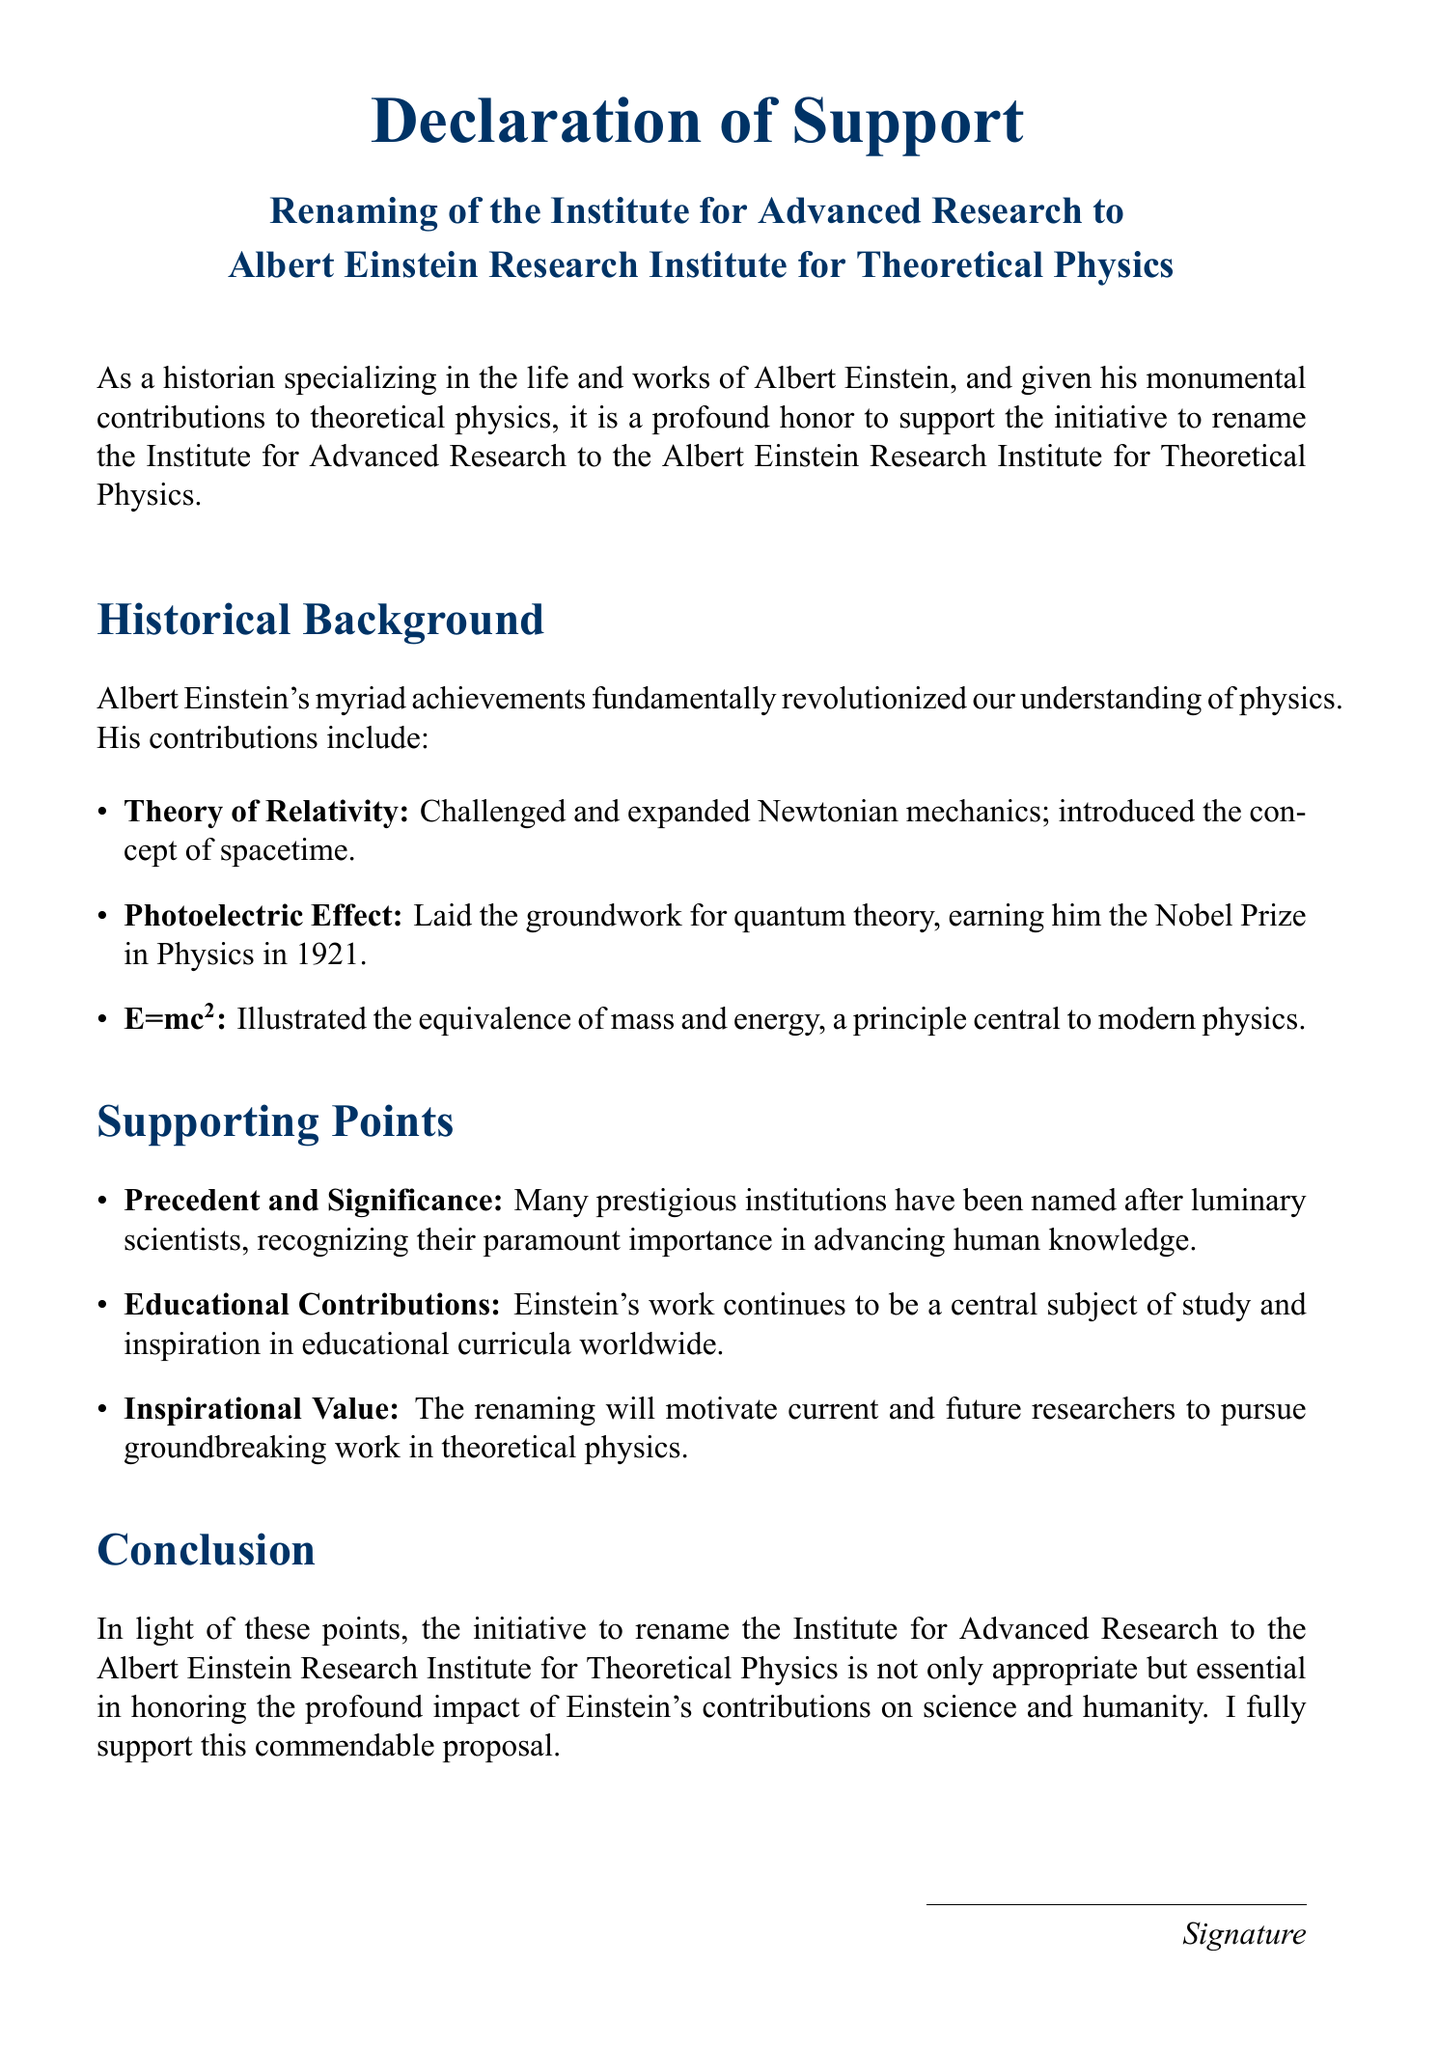What is the title of the declaration? The title of the declaration is prominently displayed at the top of the document.
Answer: Declaration of Support What is the new name proposed for the institute? The proposed name for the institute is stated clearly in the document.
Answer: Albert Einstein Research Institute for Theoretical Physics Who is the author of the declaration? The author is identified in the signature section of the document.
Answer: Dr. [Your Name] What key theory is associated with Albert Einstein? The document lists major contributions to theoretical physics.
Answer: Theory of Relativity What year did Albert Einstein win the Nobel Prize? The document mentions a specific year related to Einstein's achievements.
Answer: 1921 Why is the renaming considered significant? The document provides a rationale for the renaming based on historical context.
Answer: Recognizing paramount importance in advancing human knowledge What does E=mc² illustrate? The significance of this equation is discussed in the context of Einstein's contributions.
Answer: Equivalence of mass and energy What is one educational contribution mentioned? The document emphasizes Einstein's lasting impact on education.
Answer: Central subject of study What is the overall conclusion about the renaming initiative? The conclusion summarizes the overall sentiment toward the proposal.
Answer: Essential in honoring Einstein's contributions 